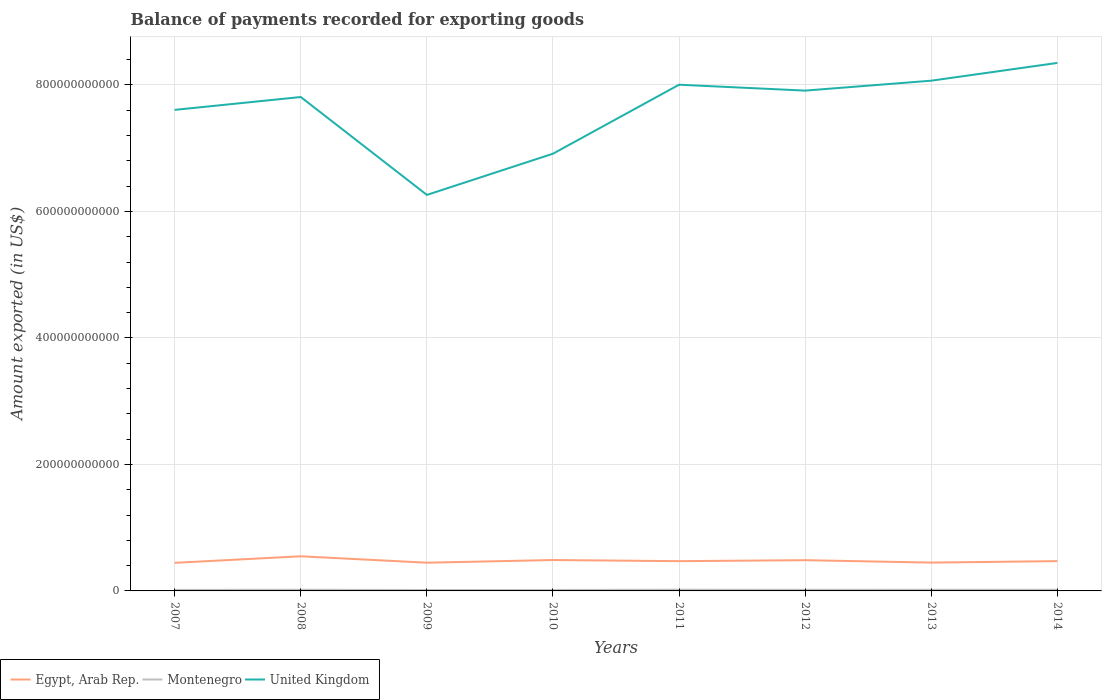Does the line corresponding to United Kingdom intersect with the line corresponding to Egypt, Arab Rep.?
Your answer should be very brief. No. Is the number of lines equal to the number of legend labels?
Make the answer very short. Yes. Across all years, what is the maximum amount exported in Egypt, Arab Rep.?
Offer a terse response. 4.44e+1. In which year was the amount exported in United Kingdom maximum?
Ensure brevity in your answer.  2009. What is the total amount exported in Montenegro in the graph?
Your answer should be very brief. -6.61e+07. What is the difference between the highest and the second highest amount exported in Egypt, Arab Rep.?
Provide a short and direct response. 1.04e+1. What is the difference between the highest and the lowest amount exported in United Kingdom?
Give a very brief answer. 5. How many years are there in the graph?
Give a very brief answer. 8. What is the difference between two consecutive major ticks on the Y-axis?
Provide a short and direct response. 2.00e+11. How many legend labels are there?
Provide a succinct answer. 3. What is the title of the graph?
Provide a short and direct response. Balance of payments recorded for exporting goods. What is the label or title of the X-axis?
Provide a succinct answer. Years. What is the label or title of the Y-axis?
Provide a succinct answer. Amount exported (in US$). What is the Amount exported (in US$) in Egypt, Arab Rep. in 2007?
Your response must be concise. 4.44e+1. What is the Amount exported (in US$) in Montenegro in 2007?
Offer a very short reply. 1.58e+09. What is the Amount exported (in US$) in United Kingdom in 2007?
Keep it short and to the point. 7.61e+11. What is the Amount exported (in US$) in Egypt, Arab Rep. in 2008?
Keep it short and to the point. 5.48e+1. What is the Amount exported (in US$) in Montenegro in 2008?
Offer a very short reply. 1.82e+09. What is the Amount exported (in US$) in United Kingdom in 2008?
Make the answer very short. 7.81e+11. What is the Amount exported (in US$) of Egypt, Arab Rep. in 2009?
Provide a short and direct response. 4.46e+1. What is the Amount exported (in US$) of Montenegro in 2009?
Your answer should be very brief. 1.44e+09. What is the Amount exported (in US$) in United Kingdom in 2009?
Your response must be concise. 6.26e+11. What is the Amount exported (in US$) of Egypt, Arab Rep. in 2010?
Keep it short and to the point. 4.88e+1. What is the Amount exported (in US$) in Montenegro in 2010?
Keep it short and to the point. 1.50e+09. What is the Amount exported (in US$) in United Kingdom in 2010?
Make the answer very short. 6.91e+11. What is the Amount exported (in US$) in Egypt, Arab Rep. in 2011?
Your response must be concise. 4.71e+1. What is the Amount exported (in US$) of Montenegro in 2011?
Provide a short and direct response. 1.93e+09. What is the Amount exported (in US$) of United Kingdom in 2011?
Your answer should be very brief. 8.00e+11. What is the Amount exported (in US$) of Egypt, Arab Rep. in 2012?
Make the answer very short. 4.86e+1. What is the Amount exported (in US$) of Montenegro in 2012?
Provide a short and direct response. 1.71e+09. What is the Amount exported (in US$) in United Kingdom in 2012?
Give a very brief answer. 7.91e+11. What is the Amount exported (in US$) of Egypt, Arab Rep. in 2013?
Provide a succinct answer. 4.48e+1. What is the Amount exported (in US$) of Montenegro in 2013?
Keep it short and to the point. 1.84e+09. What is the Amount exported (in US$) of United Kingdom in 2013?
Your response must be concise. 8.07e+11. What is the Amount exported (in US$) of Egypt, Arab Rep. in 2014?
Your answer should be very brief. 4.71e+1. What is the Amount exported (in US$) of Montenegro in 2014?
Offer a very short reply. 1.84e+09. What is the Amount exported (in US$) in United Kingdom in 2014?
Provide a succinct answer. 8.35e+11. Across all years, what is the maximum Amount exported (in US$) in Egypt, Arab Rep.?
Your answer should be very brief. 5.48e+1. Across all years, what is the maximum Amount exported (in US$) of Montenegro?
Your answer should be compact. 1.93e+09. Across all years, what is the maximum Amount exported (in US$) of United Kingdom?
Provide a short and direct response. 8.35e+11. Across all years, what is the minimum Amount exported (in US$) in Egypt, Arab Rep.?
Your response must be concise. 4.44e+1. Across all years, what is the minimum Amount exported (in US$) in Montenegro?
Ensure brevity in your answer.  1.44e+09. Across all years, what is the minimum Amount exported (in US$) of United Kingdom?
Make the answer very short. 6.26e+11. What is the total Amount exported (in US$) in Egypt, Arab Rep. in the graph?
Give a very brief answer. 3.80e+11. What is the total Amount exported (in US$) of Montenegro in the graph?
Make the answer very short. 1.37e+1. What is the total Amount exported (in US$) in United Kingdom in the graph?
Your answer should be very brief. 6.09e+12. What is the difference between the Amount exported (in US$) of Egypt, Arab Rep. in 2007 and that in 2008?
Give a very brief answer. -1.04e+1. What is the difference between the Amount exported (in US$) in Montenegro in 2007 and that in 2008?
Make the answer very short. -2.34e+08. What is the difference between the Amount exported (in US$) in United Kingdom in 2007 and that in 2008?
Keep it short and to the point. -2.04e+1. What is the difference between the Amount exported (in US$) in Egypt, Arab Rep. in 2007 and that in 2009?
Provide a short and direct response. -2.11e+08. What is the difference between the Amount exported (in US$) in Montenegro in 2007 and that in 2009?
Provide a succinct answer. 1.45e+08. What is the difference between the Amount exported (in US$) of United Kingdom in 2007 and that in 2009?
Give a very brief answer. 1.34e+11. What is the difference between the Amount exported (in US$) in Egypt, Arab Rep. in 2007 and that in 2010?
Your response must be concise. -4.43e+09. What is the difference between the Amount exported (in US$) in Montenegro in 2007 and that in 2010?
Give a very brief answer. 7.93e+07. What is the difference between the Amount exported (in US$) of United Kingdom in 2007 and that in 2010?
Your response must be concise. 6.93e+1. What is the difference between the Amount exported (in US$) of Egypt, Arab Rep. in 2007 and that in 2011?
Keep it short and to the point. -2.66e+09. What is the difference between the Amount exported (in US$) of Montenegro in 2007 and that in 2011?
Your answer should be very brief. -3.48e+08. What is the difference between the Amount exported (in US$) in United Kingdom in 2007 and that in 2011?
Your answer should be compact. -3.98e+1. What is the difference between the Amount exported (in US$) in Egypt, Arab Rep. in 2007 and that in 2012?
Your answer should be very brief. -4.20e+09. What is the difference between the Amount exported (in US$) of Montenegro in 2007 and that in 2012?
Keep it short and to the point. -1.28e+08. What is the difference between the Amount exported (in US$) of United Kingdom in 2007 and that in 2012?
Provide a succinct answer. -3.05e+1. What is the difference between the Amount exported (in US$) in Egypt, Arab Rep. in 2007 and that in 2013?
Ensure brevity in your answer.  -3.97e+08. What is the difference between the Amount exported (in US$) of Montenegro in 2007 and that in 2013?
Give a very brief answer. -2.61e+08. What is the difference between the Amount exported (in US$) in United Kingdom in 2007 and that in 2013?
Make the answer very short. -4.62e+1. What is the difference between the Amount exported (in US$) in Egypt, Arab Rep. in 2007 and that in 2014?
Provide a succinct answer. -2.70e+09. What is the difference between the Amount exported (in US$) of Montenegro in 2007 and that in 2014?
Your answer should be compact. -2.60e+08. What is the difference between the Amount exported (in US$) in United Kingdom in 2007 and that in 2014?
Provide a succinct answer. -7.42e+1. What is the difference between the Amount exported (in US$) of Egypt, Arab Rep. in 2008 and that in 2009?
Ensure brevity in your answer.  1.02e+1. What is the difference between the Amount exported (in US$) of Montenegro in 2008 and that in 2009?
Keep it short and to the point. 3.79e+08. What is the difference between the Amount exported (in US$) of United Kingdom in 2008 and that in 2009?
Make the answer very short. 1.55e+11. What is the difference between the Amount exported (in US$) of Egypt, Arab Rep. in 2008 and that in 2010?
Provide a succinct answer. 5.93e+09. What is the difference between the Amount exported (in US$) in Montenegro in 2008 and that in 2010?
Your answer should be very brief. 3.13e+08. What is the difference between the Amount exported (in US$) in United Kingdom in 2008 and that in 2010?
Your response must be concise. 8.96e+1. What is the difference between the Amount exported (in US$) of Egypt, Arab Rep. in 2008 and that in 2011?
Your response must be concise. 7.71e+09. What is the difference between the Amount exported (in US$) of Montenegro in 2008 and that in 2011?
Ensure brevity in your answer.  -1.14e+08. What is the difference between the Amount exported (in US$) in United Kingdom in 2008 and that in 2011?
Your response must be concise. -1.95e+1. What is the difference between the Amount exported (in US$) in Egypt, Arab Rep. in 2008 and that in 2012?
Your answer should be compact. 6.16e+09. What is the difference between the Amount exported (in US$) in Montenegro in 2008 and that in 2012?
Ensure brevity in your answer.  1.06e+08. What is the difference between the Amount exported (in US$) in United Kingdom in 2008 and that in 2012?
Keep it short and to the point. -1.01e+1. What is the difference between the Amount exported (in US$) in Egypt, Arab Rep. in 2008 and that in 2013?
Offer a very short reply. 9.97e+09. What is the difference between the Amount exported (in US$) in Montenegro in 2008 and that in 2013?
Make the answer very short. -2.67e+07. What is the difference between the Amount exported (in US$) in United Kingdom in 2008 and that in 2013?
Provide a short and direct response. -2.58e+1. What is the difference between the Amount exported (in US$) of Egypt, Arab Rep. in 2008 and that in 2014?
Make the answer very short. 7.66e+09. What is the difference between the Amount exported (in US$) in Montenegro in 2008 and that in 2014?
Your response must be concise. -2.57e+07. What is the difference between the Amount exported (in US$) in United Kingdom in 2008 and that in 2014?
Provide a short and direct response. -5.39e+1. What is the difference between the Amount exported (in US$) in Egypt, Arab Rep. in 2009 and that in 2010?
Your response must be concise. -4.22e+09. What is the difference between the Amount exported (in US$) of Montenegro in 2009 and that in 2010?
Offer a very short reply. -6.61e+07. What is the difference between the Amount exported (in US$) of United Kingdom in 2009 and that in 2010?
Provide a succinct answer. -6.51e+1. What is the difference between the Amount exported (in US$) of Egypt, Arab Rep. in 2009 and that in 2011?
Provide a short and direct response. -2.44e+09. What is the difference between the Amount exported (in US$) in Montenegro in 2009 and that in 2011?
Keep it short and to the point. -4.93e+08. What is the difference between the Amount exported (in US$) in United Kingdom in 2009 and that in 2011?
Provide a succinct answer. -1.74e+11. What is the difference between the Amount exported (in US$) of Egypt, Arab Rep. in 2009 and that in 2012?
Your answer should be very brief. -3.99e+09. What is the difference between the Amount exported (in US$) in Montenegro in 2009 and that in 2012?
Provide a short and direct response. -2.73e+08. What is the difference between the Amount exported (in US$) of United Kingdom in 2009 and that in 2012?
Your response must be concise. -1.65e+11. What is the difference between the Amount exported (in US$) of Egypt, Arab Rep. in 2009 and that in 2013?
Provide a succinct answer. -1.86e+08. What is the difference between the Amount exported (in US$) in Montenegro in 2009 and that in 2013?
Your answer should be very brief. -4.06e+08. What is the difference between the Amount exported (in US$) in United Kingdom in 2009 and that in 2013?
Make the answer very short. -1.81e+11. What is the difference between the Amount exported (in US$) in Egypt, Arab Rep. in 2009 and that in 2014?
Give a very brief answer. -2.49e+09. What is the difference between the Amount exported (in US$) of Montenegro in 2009 and that in 2014?
Your answer should be compact. -4.05e+08. What is the difference between the Amount exported (in US$) in United Kingdom in 2009 and that in 2014?
Provide a succinct answer. -2.09e+11. What is the difference between the Amount exported (in US$) of Egypt, Arab Rep. in 2010 and that in 2011?
Provide a short and direct response. 1.78e+09. What is the difference between the Amount exported (in US$) of Montenegro in 2010 and that in 2011?
Ensure brevity in your answer.  -4.27e+08. What is the difference between the Amount exported (in US$) of United Kingdom in 2010 and that in 2011?
Ensure brevity in your answer.  -1.09e+11. What is the difference between the Amount exported (in US$) in Egypt, Arab Rep. in 2010 and that in 2012?
Your answer should be very brief. 2.30e+08. What is the difference between the Amount exported (in US$) of Montenegro in 2010 and that in 2012?
Your answer should be very brief. -2.07e+08. What is the difference between the Amount exported (in US$) in United Kingdom in 2010 and that in 2012?
Provide a short and direct response. -9.97e+1. What is the difference between the Amount exported (in US$) in Egypt, Arab Rep. in 2010 and that in 2013?
Provide a short and direct response. 4.04e+09. What is the difference between the Amount exported (in US$) in Montenegro in 2010 and that in 2013?
Offer a terse response. -3.40e+08. What is the difference between the Amount exported (in US$) of United Kingdom in 2010 and that in 2013?
Offer a terse response. -1.15e+11. What is the difference between the Amount exported (in US$) of Egypt, Arab Rep. in 2010 and that in 2014?
Offer a terse response. 1.73e+09. What is the difference between the Amount exported (in US$) of Montenegro in 2010 and that in 2014?
Offer a terse response. -3.39e+08. What is the difference between the Amount exported (in US$) in United Kingdom in 2010 and that in 2014?
Your answer should be very brief. -1.44e+11. What is the difference between the Amount exported (in US$) of Egypt, Arab Rep. in 2011 and that in 2012?
Provide a succinct answer. -1.55e+09. What is the difference between the Amount exported (in US$) of Montenegro in 2011 and that in 2012?
Keep it short and to the point. 2.20e+08. What is the difference between the Amount exported (in US$) of United Kingdom in 2011 and that in 2012?
Keep it short and to the point. 9.33e+09. What is the difference between the Amount exported (in US$) of Egypt, Arab Rep. in 2011 and that in 2013?
Provide a short and direct response. 2.26e+09. What is the difference between the Amount exported (in US$) in Montenegro in 2011 and that in 2013?
Keep it short and to the point. 8.72e+07. What is the difference between the Amount exported (in US$) in United Kingdom in 2011 and that in 2013?
Offer a very short reply. -6.37e+09. What is the difference between the Amount exported (in US$) in Egypt, Arab Rep. in 2011 and that in 2014?
Your answer should be very brief. -4.83e+07. What is the difference between the Amount exported (in US$) in Montenegro in 2011 and that in 2014?
Offer a very short reply. 8.82e+07. What is the difference between the Amount exported (in US$) in United Kingdom in 2011 and that in 2014?
Keep it short and to the point. -3.44e+1. What is the difference between the Amount exported (in US$) in Egypt, Arab Rep. in 2012 and that in 2013?
Your response must be concise. 3.81e+09. What is the difference between the Amount exported (in US$) in Montenegro in 2012 and that in 2013?
Offer a very short reply. -1.33e+08. What is the difference between the Amount exported (in US$) in United Kingdom in 2012 and that in 2013?
Your response must be concise. -1.57e+1. What is the difference between the Amount exported (in US$) of Egypt, Arab Rep. in 2012 and that in 2014?
Provide a succinct answer. 1.50e+09. What is the difference between the Amount exported (in US$) in Montenegro in 2012 and that in 2014?
Your answer should be very brief. -1.32e+08. What is the difference between the Amount exported (in US$) in United Kingdom in 2012 and that in 2014?
Provide a short and direct response. -4.38e+1. What is the difference between the Amount exported (in US$) in Egypt, Arab Rep. in 2013 and that in 2014?
Your answer should be very brief. -2.31e+09. What is the difference between the Amount exported (in US$) of Montenegro in 2013 and that in 2014?
Your answer should be compact. 9.82e+05. What is the difference between the Amount exported (in US$) of United Kingdom in 2013 and that in 2014?
Offer a very short reply. -2.81e+1. What is the difference between the Amount exported (in US$) of Egypt, Arab Rep. in 2007 and the Amount exported (in US$) of Montenegro in 2008?
Your response must be concise. 4.26e+1. What is the difference between the Amount exported (in US$) of Egypt, Arab Rep. in 2007 and the Amount exported (in US$) of United Kingdom in 2008?
Provide a succinct answer. -7.36e+11. What is the difference between the Amount exported (in US$) in Montenegro in 2007 and the Amount exported (in US$) in United Kingdom in 2008?
Provide a short and direct response. -7.79e+11. What is the difference between the Amount exported (in US$) in Egypt, Arab Rep. in 2007 and the Amount exported (in US$) in Montenegro in 2009?
Offer a terse response. 4.30e+1. What is the difference between the Amount exported (in US$) in Egypt, Arab Rep. in 2007 and the Amount exported (in US$) in United Kingdom in 2009?
Your answer should be very brief. -5.82e+11. What is the difference between the Amount exported (in US$) of Montenegro in 2007 and the Amount exported (in US$) of United Kingdom in 2009?
Keep it short and to the point. -6.25e+11. What is the difference between the Amount exported (in US$) in Egypt, Arab Rep. in 2007 and the Amount exported (in US$) in Montenegro in 2010?
Provide a short and direct response. 4.29e+1. What is the difference between the Amount exported (in US$) of Egypt, Arab Rep. in 2007 and the Amount exported (in US$) of United Kingdom in 2010?
Provide a succinct answer. -6.47e+11. What is the difference between the Amount exported (in US$) of Montenegro in 2007 and the Amount exported (in US$) of United Kingdom in 2010?
Ensure brevity in your answer.  -6.90e+11. What is the difference between the Amount exported (in US$) in Egypt, Arab Rep. in 2007 and the Amount exported (in US$) in Montenegro in 2011?
Your response must be concise. 4.25e+1. What is the difference between the Amount exported (in US$) in Egypt, Arab Rep. in 2007 and the Amount exported (in US$) in United Kingdom in 2011?
Your response must be concise. -7.56e+11. What is the difference between the Amount exported (in US$) of Montenegro in 2007 and the Amount exported (in US$) of United Kingdom in 2011?
Your answer should be compact. -7.99e+11. What is the difference between the Amount exported (in US$) in Egypt, Arab Rep. in 2007 and the Amount exported (in US$) in Montenegro in 2012?
Make the answer very short. 4.27e+1. What is the difference between the Amount exported (in US$) in Egypt, Arab Rep. in 2007 and the Amount exported (in US$) in United Kingdom in 2012?
Provide a succinct answer. -7.47e+11. What is the difference between the Amount exported (in US$) of Montenegro in 2007 and the Amount exported (in US$) of United Kingdom in 2012?
Ensure brevity in your answer.  -7.89e+11. What is the difference between the Amount exported (in US$) of Egypt, Arab Rep. in 2007 and the Amount exported (in US$) of Montenegro in 2013?
Your response must be concise. 4.26e+1. What is the difference between the Amount exported (in US$) in Egypt, Arab Rep. in 2007 and the Amount exported (in US$) in United Kingdom in 2013?
Provide a short and direct response. -7.62e+11. What is the difference between the Amount exported (in US$) of Montenegro in 2007 and the Amount exported (in US$) of United Kingdom in 2013?
Give a very brief answer. -8.05e+11. What is the difference between the Amount exported (in US$) in Egypt, Arab Rep. in 2007 and the Amount exported (in US$) in Montenegro in 2014?
Offer a terse response. 4.26e+1. What is the difference between the Amount exported (in US$) in Egypt, Arab Rep. in 2007 and the Amount exported (in US$) in United Kingdom in 2014?
Provide a short and direct response. -7.90e+11. What is the difference between the Amount exported (in US$) of Montenegro in 2007 and the Amount exported (in US$) of United Kingdom in 2014?
Your answer should be very brief. -8.33e+11. What is the difference between the Amount exported (in US$) of Egypt, Arab Rep. in 2008 and the Amount exported (in US$) of Montenegro in 2009?
Provide a succinct answer. 5.33e+1. What is the difference between the Amount exported (in US$) of Egypt, Arab Rep. in 2008 and the Amount exported (in US$) of United Kingdom in 2009?
Make the answer very short. -5.71e+11. What is the difference between the Amount exported (in US$) of Montenegro in 2008 and the Amount exported (in US$) of United Kingdom in 2009?
Provide a succinct answer. -6.24e+11. What is the difference between the Amount exported (in US$) of Egypt, Arab Rep. in 2008 and the Amount exported (in US$) of Montenegro in 2010?
Offer a very short reply. 5.33e+1. What is the difference between the Amount exported (in US$) in Egypt, Arab Rep. in 2008 and the Amount exported (in US$) in United Kingdom in 2010?
Your response must be concise. -6.37e+11. What is the difference between the Amount exported (in US$) in Montenegro in 2008 and the Amount exported (in US$) in United Kingdom in 2010?
Offer a very short reply. -6.89e+11. What is the difference between the Amount exported (in US$) of Egypt, Arab Rep. in 2008 and the Amount exported (in US$) of Montenegro in 2011?
Ensure brevity in your answer.  5.28e+1. What is the difference between the Amount exported (in US$) of Egypt, Arab Rep. in 2008 and the Amount exported (in US$) of United Kingdom in 2011?
Offer a terse response. -7.46e+11. What is the difference between the Amount exported (in US$) of Montenegro in 2008 and the Amount exported (in US$) of United Kingdom in 2011?
Provide a succinct answer. -7.99e+11. What is the difference between the Amount exported (in US$) in Egypt, Arab Rep. in 2008 and the Amount exported (in US$) in Montenegro in 2012?
Provide a succinct answer. 5.31e+1. What is the difference between the Amount exported (in US$) of Egypt, Arab Rep. in 2008 and the Amount exported (in US$) of United Kingdom in 2012?
Offer a very short reply. -7.36e+11. What is the difference between the Amount exported (in US$) of Montenegro in 2008 and the Amount exported (in US$) of United Kingdom in 2012?
Keep it short and to the point. -7.89e+11. What is the difference between the Amount exported (in US$) in Egypt, Arab Rep. in 2008 and the Amount exported (in US$) in Montenegro in 2013?
Keep it short and to the point. 5.29e+1. What is the difference between the Amount exported (in US$) of Egypt, Arab Rep. in 2008 and the Amount exported (in US$) of United Kingdom in 2013?
Offer a terse response. -7.52e+11. What is the difference between the Amount exported (in US$) of Montenegro in 2008 and the Amount exported (in US$) of United Kingdom in 2013?
Ensure brevity in your answer.  -8.05e+11. What is the difference between the Amount exported (in US$) in Egypt, Arab Rep. in 2008 and the Amount exported (in US$) in Montenegro in 2014?
Your answer should be very brief. 5.29e+1. What is the difference between the Amount exported (in US$) of Egypt, Arab Rep. in 2008 and the Amount exported (in US$) of United Kingdom in 2014?
Keep it short and to the point. -7.80e+11. What is the difference between the Amount exported (in US$) in Montenegro in 2008 and the Amount exported (in US$) in United Kingdom in 2014?
Provide a short and direct response. -8.33e+11. What is the difference between the Amount exported (in US$) in Egypt, Arab Rep. in 2009 and the Amount exported (in US$) in Montenegro in 2010?
Offer a terse response. 4.31e+1. What is the difference between the Amount exported (in US$) of Egypt, Arab Rep. in 2009 and the Amount exported (in US$) of United Kingdom in 2010?
Keep it short and to the point. -6.47e+11. What is the difference between the Amount exported (in US$) of Montenegro in 2009 and the Amount exported (in US$) of United Kingdom in 2010?
Provide a succinct answer. -6.90e+11. What is the difference between the Amount exported (in US$) in Egypt, Arab Rep. in 2009 and the Amount exported (in US$) in Montenegro in 2011?
Keep it short and to the point. 4.27e+1. What is the difference between the Amount exported (in US$) of Egypt, Arab Rep. in 2009 and the Amount exported (in US$) of United Kingdom in 2011?
Your response must be concise. -7.56e+11. What is the difference between the Amount exported (in US$) in Montenegro in 2009 and the Amount exported (in US$) in United Kingdom in 2011?
Ensure brevity in your answer.  -7.99e+11. What is the difference between the Amount exported (in US$) of Egypt, Arab Rep. in 2009 and the Amount exported (in US$) of Montenegro in 2012?
Provide a succinct answer. 4.29e+1. What is the difference between the Amount exported (in US$) of Egypt, Arab Rep. in 2009 and the Amount exported (in US$) of United Kingdom in 2012?
Provide a succinct answer. -7.46e+11. What is the difference between the Amount exported (in US$) of Montenegro in 2009 and the Amount exported (in US$) of United Kingdom in 2012?
Keep it short and to the point. -7.90e+11. What is the difference between the Amount exported (in US$) in Egypt, Arab Rep. in 2009 and the Amount exported (in US$) in Montenegro in 2013?
Your answer should be very brief. 4.28e+1. What is the difference between the Amount exported (in US$) in Egypt, Arab Rep. in 2009 and the Amount exported (in US$) in United Kingdom in 2013?
Provide a short and direct response. -7.62e+11. What is the difference between the Amount exported (in US$) in Montenegro in 2009 and the Amount exported (in US$) in United Kingdom in 2013?
Your response must be concise. -8.05e+11. What is the difference between the Amount exported (in US$) of Egypt, Arab Rep. in 2009 and the Amount exported (in US$) of Montenegro in 2014?
Provide a succinct answer. 4.28e+1. What is the difference between the Amount exported (in US$) of Egypt, Arab Rep. in 2009 and the Amount exported (in US$) of United Kingdom in 2014?
Offer a very short reply. -7.90e+11. What is the difference between the Amount exported (in US$) of Montenegro in 2009 and the Amount exported (in US$) of United Kingdom in 2014?
Give a very brief answer. -8.33e+11. What is the difference between the Amount exported (in US$) in Egypt, Arab Rep. in 2010 and the Amount exported (in US$) in Montenegro in 2011?
Provide a succinct answer. 4.69e+1. What is the difference between the Amount exported (in US$) in Egypt, Arab Rep. in 2010 and the Amount exported (in US$) in United Kingdom in 2011?
Keep it short and to the point. -7.52e+11. What is the difference between the Amount exported (in US$) of Montenegro in 2010 and the Amount exported (in US$) of United Kingdom in 2011?
Your answer should be compact. -7.99e+11. What is the difference between the Amount exported (in US$) of Egypt, Arab Rep. in 2010 and the Amount exported (in US$) of Montenegro in 2012?
Provide a succinct answer. 4.71e+1. What is the difference between the Amount exported (in US$) of Egypt, Arab Rep. in 2010 and the Amount exported (in US$) of United Kingdom in 2012?
Offer a terse response. -7.42e+11. What is the difference between the Amount exported (in US$) in Montenegro in 2010 and the Amount exported (in US$) in United Kingdom in 2012?
Ensure brevity in your answer.  -7.90e+11. What is the difference between the Amount exported (in US$) of Egypt, Arab Rep. in 2010 and the Amount exported (in US$) of Montenegro in 2013?
Keep it short and to the point. 4.70e+1. What is the difference between the Amount exported (in US$) of Egypt, Arab Rep. in 2010 and the Amount exported (in US$) of United Kingdom in 2013?
Your answer should be compact. -7.58e+11. What is the difference between the Amount exported (in US$) of Montenegro in 2010 and the Amount exported (in US$) of United Kingdom in 2013?
Your answer should be very brief. -8.05e+11. What is the difference between the Amount exported (in US$) of Egypt, Arab Rep. in 2010 and the Amount exported (in US$) of Montenegro in 2014?
Offer a terse response. 4.70e+1. What is the difference between the Amount exported (in US$) of Egypt, Arab Rep. in 2010 and the Amount exported (in US$) of United Kingdom in 2014?
Keep it short and to the point. -7.86e+11. What is the difference between the Amount exported (in US$) in Montenegro in 2010 and the Amount exported (in US$) in United Kingdom in 2014?
Your answer should be compact. -8.33e+11. What is the difference between the Amount exported (in US$) in Egypt, Arab Rep. in 2011 and the Amount exported (in US$) in Montenegro in 2012?
Keep it short and to the point. 4.53e+1. What is the difference between the Amount exported (in US$) of Egypt, Arab Rep. in 2011 and the Amount exported (in US$) of United Kingdom in 2012?
Ensure brevity in your answer.  -7.44e+11. What is the difference between the Amount exported (in US$) in Montenegro in 2011 and the Amount exported (in US$) in United Kingdom in 2012?
Offer a very short reply. -7.89e+11. What is the difference between the Amount exported (in US$) in Egypt, Arab Rep. in 2011 and the Amount exported (in US$) in Montenegro in 2013?
Your answer should be compact. 4.52e+1. What is the difference between the Amount exported (in US$) in Egypt, Arab Rep. in 2011 and the Amount exported (in US$) in United Kingdom in 2013?
Your answer should be compact. -7.60e+11. What is the difference between the Amount exported (in US$) of Montenegro in 2011 and the Amount exported (in US$) of United Kingdom in 2013?
Offer a very short reply. -8.05e+11. What is the difference between the Amount exported (in US$) of Egypt, Arab Rep. in 2011 and the Amount exported (in US$) of Montenegro in 2014?
Offer a very short reply. 4.52e+1. What is the difference between the Amount exported (in US$) of Egypt, Arab Rep. in 2011 and the Amount exported (in US$) of United Kingdom in 2014?
Provide a succinct answer. -7.88e+11. What is the difference between the Amount exported (in US$) of Montenegro in 2011 and the Amount exported (in US$) of United Kingdom in 2014?
Provide a short and direct response. -8.33e+11. What is the difference between the Amount exported (in US$) in Egypt, Arab Rep. in 2012 and the Amount exported (in US$) in Montenegro in 2013?
Offer a very short reply. 4.68e+1. What is the difference between the Amount exported (in US$) of Egypt, Arab Rep. in 2012 and the Amount exported (in US$) of United Kingdom in 2013?
Your response must be concise. -7.58e+11. What is the difference between the Amount exported (in US$) in Montenegro in 2012 and the Amount exported (in US$) in United Kingdom in 2013?
Offer a very short reply. -8.05e+11. What is the difference between the Amount exported (in US$) in Egypt, Arab Rep. in 2012 and the Amount exported (in US$) in Montenegro in 2014?
Keep it short and to the point. 4.68e+1. What is the difference between the Amount exported (in US$) in Egypt, Arab Rep. in 2012 and the Amount exported (in US$) in United Kingdom in 2014?
Offer a very short reply. -7.86e+11. What is the difference between the Amount exported (in US$) in Montenegro in 2012 and the Amount exported (in US$) in United Kingdom in 2014?
Your answer should be compact. -8.33e+11. What is the difference between the Amount exported (in US$) of Egypt, Arab Rep. in 2013 and the Amount exported (in US$) of Montenegro in 2014?
Your answer should be compact. 4.30e+1. What is the difference between the Amount exported (in US$) in Egypt, Arab Rep. in 2013 and the Amount exported (in US$) in United Kingdom in 2014?
Ensure brevity in your answer.  -7.90e+11. What is the difference between the Amount exported (in US$) of Montenegro in 2013 and the Amount exported (in US$) of United Kingdom in 2014?
Provide a succinct answer. -8.33e+11. What is the average Amount exported (in US$) of Egypt, Arab Rep. per year?
Keep it short and to the point. 4.75e+1. What is the average Amount exported (in US$) of Montenegro per year?
Offer a very short reply. 1.71e+09. What is the average Amount exported (in US$) in United Kingdom per year?
Your answer should be very brief. 7.61e+11. In the year 2007, what is the difference between the Amount exported (in US$) in Egypt, Arab Rep. and Amount exported (in US$) in Montenegro?
Provide a succinct answer. 4.28e+1. In the year 2007, what is the difference between the Amount exported (in US$) in Egypt, Arab Rep. and Amount exported (in US$) in United Kingdom?
Provide a succinct answer. -7.16e+11. In the year 2007, what is the difference between the Amount exported (in US$) of Montenegro and Amount exported (in US$) of United Kingdom?
Ensure brevity in your answer.  -7.59e+11. In the year 2008, what is the difference between the Amount exported (in US$) in Egypt, Arab Rep. and Amount exported (in US$) in Montenegro?
Provide a succinct answer. 5.29e+1. In the year 2008, what is the difference between the Amount exported (in US$) in Egypt, Arab Rep. and Amount exported (in US$) in United Kingdom?
Provide a short and direct response. -7.26e+11. In the year 2008, what is the difference between the Amount exported (in US$) of Montenegro and Amount exported (in US$) of United Kingdom?
Your answer should be compact. -7.79e+11. In the year 2009, what is the difference between the Amount exported (in US$) of Egypt, Arab Rep. and Amount exported (in US$) of Montenegro?
Make the answer very short. 4.32e+1. In the year 2009, what is the difference between the Amount exported (in US$) in Egypt, Arab Rep. and Amount exported (in US$) in United Kingdom?
Keep it short and to the point. -5.82e+11. In the year 2009, what is the difference between the Amount exported (in US$) of Montenegro and Amount exported (in US$) of United Kingdom?
Give a very brief answer. -6.25e+11. In the year 2010, what is the difference between the Amount exported (in US$) in Egypt, Arab Rep. and Amount exported (in US$) in Montenegro?
Ensure brevity in your answer.  4.73e+1. In the year 2010, what is the difference between the Amount exported (in US$) of Egypt, Arab Rep. and Amount exported (in US$) of United Kingdom?
Give a very brief answer. -6.42e+11. In the year 2010, what is the difference between the Amount exported (in US$) of Montenegro and Amount exported (in US$) of United Kingdom?
Your answer should be compact. -6.90e+11. In the year 2011, what is the difference between the Amount exported (in US$) of Egypt, Arab Rep. and Amount exported (in US$) of Montenegro?
Keep it short and to the point. 4.51e+1. In the year 2011, what is the difference between the Amount exported (in US$) in Egypt, Arab Rep. and Amount exported (in US$) in United Kingdom?
Make the answer very short. -7.53e+11. In the year 2011, what is the difference between the Amount exported (in US$) of Montenegro and Amount exported (in US$) of United Kingdom?
Offer a terse response. -7.98e+11. In the year 2012, what is the difference between the Amount exported (in US$) in Egypt, Arab Rep. and Amount exported (in US$) in Montenegro?
Your response must be concise. 4.69e+1. In the year 2012, what is the difference between the Amount exported (in US$) in Egypt, Arab Rep. and Amount exported (in US$) in United Kingdom?
Provide a succinct answer. -7.42e+11. In the year 2012, what is the difference between the Amount exported (in US$) of Montenegro and Amount exported (in US$) of United Kingdom?
Make the answer very short. -7.89e+11. In the year 2013, what is the difference between the Amount exported (in US$) of Egypt, Arab Rep. and Amount exported (in US$) of Montenegro?
Offer a very short reply. 4.30e+1. In the year 2013, what is the difference between the Amount exported (in US$) of Egypt, Arab Rep. and Amount exported (in US$) of United Kingdom?
Ensure brevity in your answer.  -7.62e+11. In the year 2013, what is the difference between the Amount exported (in US$) of Montenegro and Amount exported (in US$) of United Kingdom?
Provide a short and direct response. -8.05e+11. In the year 2014, what is the difference between the Amount exported (in US$) of Egypt, Arab Rep. and Amount exported (in US$) of Montenegro?
Provide a succinct answer. 4.53e+1. In the year 2014, what is the difference between the Amount exported (in US$) of Egypt, Arab Rep. and Amount exported (in US$) of United Kingdom?
Offer a very short reply. -7.88e+11. In the year 2014, what is the difference between the Amount exported (in US$) in Montenegro and Amount exported (in US$) in United Kingdom?
Offer a very short reply. -8.33e+11. What is the ratio of the Amount exported (in US$) of Egypt, Arab Rep. in 2007 to that in 2008?
Offer a very short reply. 0.81. What is the ratio of the Amount exported (in US$) in Montenegro in 2007 to that in 2008?
Keep it short and to the point. 0.87. What is the ratio of the Amount exported (in US$) of United Kingdom in 2007 to that in 2008?
Give a very brief answer. 0.97. What is the ratio of the Amount exported (in US$) in Egypt, Arab Rep. in 2007 to that in 2009?
Provide a succinct answer. 1. What is the ratio of the Amount exported (in US$) in Montenegro in 2007 to that in 2009?
Your answer should be very brief. 1.1. What is the ratio of the Amount exported (in US$) in United Kingdom in 2007 to that in 2009?
Your answer should be very brief. 1.21. What is the ratio of the Amount exported (in US$) of Egypt, Arab Rep. in 2007 to that in 2010?
Your answer should be very brief. 0.91. What is the ratio of the Amount exported (in US$) in Montenegro in 2007 to that in 2010?
Offer a terse response. 1.05. What is the ratio of the Amount exported (in US$) of United Kingdom in 2007 to that in 2010?
Your answer should be compact. 1.1. What is the ratio of the Amount exported (in US$) of Egypt, Arab Rep. in 2007 to that in 2011?
Make the answer very short. 0.94. What is the ratio of the Amount exported (in US$) of Montenegro in 2007 to that in 2011?
Provide a succinct answer. 0.82. What is the ratio of the Amount exported (in US$) of United Kingdom in 2007 to that in 2011?
Your answer should be very brief. 0.95. What is the ratio of the Amount exported (in US$) in Egypt, Arab Rep. in 2007 to that in 2012?
Your answer should be compact. 0.91. What is the ratio of the Amount exported (in US$) of Montenegro in 2007 to that in 2012?
Give a very brief answer. 0.93. What is the ratio of the Amount exported (in US$) in United Kingdom in 2007 to that in 2012?
Your answer should be compact. 0.96. What is the ratio of the Amount exported (in US$) of Egypt, Arab Rep. in 2007 to that in 2013?
Ensure brevity in your answer.  0.99. What is the ratio of the Amount exported (in US$) of Montenegro in 2007 to that in 2013?
Make the answer very short. 0.86. What is the ratio of the Amount exported (in US$) of United Kingdom in 2007 to that in 2013?
Provide a succinct answer. 0.94. What is the ratio of the Amount exported (in US$) of Egypt, Arab Rep. in 2007 to that in 2014?
Ensure brevity in your answer.  0.94. What is the ratio of the Amount exported (in US$) of Montenegro in 2007 to that in 2014?
Your answer should be compact. 0.86. What is the ratio of the Amount exported (in US$) of United Kingdom in 2007 to that in 2014?
Ensure brevity in your answer.  0.91. What is the ratio of the Amount exported (in US$) in Egypt, Arab Rep. in 2008 to that in 2009?
Provide a succinct answer. 1.23. What is the ratio of the Amount exported (in US$) in Montenegro in 2008 to that in 2009?
Ensure brevity in your answer.  1.26. What is the ratio of the Amount exported (in US$) of United Kingdom in 2008 to that in 2009?
Give a very brief answer. 1.25. What is the ratio of the Amount exported (in US$) of Egypt, Arab Rep. in 2008 to that in 2010?
Ensure brevity in your answer.  1.12. What is the ratio of the Amount exported (in US$) of Montenegro in 2008 to that in 2010?
Offer a terse response. 1.21. What is the ratio of the Amount exported (in US$) in United Kingdom in 2008 to that in 2010?
Ensure brevity in your answer.  1.13. What is the ratio of the Amount exported (in US$) of Egypt, Arab Rep. in 2008 to that in 2011?
Your answer should be compact. 1.16. What is the ratio of the Amount exported (in US$) in Montenegro in 2008 to that in 2011?
Provide a succinct answer. 0.94. What is the ratio of the Amount exported (in US$) in United Kingdom in 2008 to that in 2011?
Offer a terse response. 0.98. What is the ratio of the Amount exported (in US$) of Egypt, Arab Rep. in 2008 to that in 2012?
Keep it short and to the point. 1.13. What is the ratio of the Amount exported (in US$) of Montenegro in 2008 to that in 2012?
Offer a terse response. 1.06. What is the ratio of the Amount exported (in US$) in United Kingdom in 2008 to that in 2012?
Provide a short and direct response. 0.99. What is the ratio of the Amount exported (in US$) in Egypt, Arab Rep. in 2008 to that in 2013?
Give a very brief answer. 1.22. What is the ratio of the Amount exported (in US$) of Montenegro in 2008 to that in 2013?
Provide a short and direct response. 0.99. What is the ratio of the Amount exported (in US$) in Egypt, Arab Rep. in 2008 to that in 2014?
Keep it short and to the point. 1.16. What is the ratio of the Amount exported (in US$) in United Kingdom in 2008 to that in 2014?
Offer a very short reply. 0.94. What is the ratio of the Amount exported (in US$) in Egypt, Arab Rep. in 2009 to that in 2010?
Provide a short and direct response. 0.91. What is the ratio of the Amount exported (in US$) in Montenegro in 2009 to that in 2010?
Your answer should be compact. 0.96. What is the ratio of the Amount exported (in US$) in United Kingdom in 2009 to that in 2010?
Keep it short and to the point. 0.91. What is the ratio of the Amount exported (in US$) of Egypt, Arab Rep. in 2009 to that in 2011?
Give a very brief answer. 0.95. What is the ratio of the Amount exported (in US$) of Montenegro in 2009 to that in 2011?
Make the answer very short. 0.74. What is the ratio of the Amount exported (in US$) in United Kingdom in 2009 to that in 2011?
Offer a terse response. 0.78. What is the ratio of the Amount exported (in US$) in Egypt, Arab Rep. in 2009 to that in 2012?
Make the answer very short. 0.92. What is the ratio of the Amount exported (in US$) in Montenegro in 2009 to that in 2012?
Make the answer very short. 0.84. What is the ratio of the Amount exported (in US$) in United Kingdom in 2009 to that in 2012?
Give a very brief answer. 0.79. What is the ratio of the Amount exported (in US$) of Montenegro in 2009 to that in 2013?
Your answer should be compact. 0.78. What is the ratio of the Amount exported (in US$) in United Kingdom in 2009 to that in 2013?
Make the answer very short. 0.78. What is the ratio of the Amount exported (in US$) in Egypt, Arab Rep. in 2009 to that in 2014?
Keep it short and to the point. 0.95. What is the ratio of the Amount exported (in US$) of Montenegro in 2009 to that in 2014?
Your response must be concise. 0.78. What is the ratio of the Amount exported (in US$) in United Kingdom in 2009 to that in 2014?
Offer a terse response. 0.75. What is the ratio of the Amount exported (in US$) in Egypt, Arab Rep. in 2010 to that in 2011?
Your response must be concise. 1.04. What is the ratio of the Amount exported (in US$) of Montenegro in 2010 to that in 2011?
Your answer should be compact. 0.78. What is the ratio of the Amount exported (in US$) of United Kingdom in 2010 to that in 2011?
Offer a terse response. 0.86. What is the ratio of the Amount exported (in US$) in Montenegro in 2010 to that in 2012?
Offer a very short reply. 0.88. What is the ratio of the Amount exported (in US$) of United Kingdom in 2010 to that in 2012?
Make the answer very short. 0.87. What is the ratio of the Amount exported (in US$) in Egypt, Arab Rep. in 2010 to that in 2013?
Provide a succinct answer. 1.09. What is the ratio of the Amount exported (in US$) of Montenegro in 2010 to that in 2013?
Make the answer very short. 0.82. What is the ratio of the Amount exported (in US$) in United Kingdom in 2010 to that in 2013?
Ensure brevity in your answer.  0.86. What is the ratio of the Amount exported (in US$) in Egypt, Arab Rep. in 2010 to that in 2014?
Give a very brief answer. 1.04. What is the ratio of the Amount exported (in US$) in Montenegro in 2010 to that in 2014?
Ensure brevity in your answer.  0.82. What is the ratio of the Amount exported (in US$) in United Kingdom in 2010 to that in 2014?
Your response must be concise. 0.83. What is the ratio of the Amount exported (in US$) of Egypt, Arab Rep. in 2011 to that in 2012?
Offer a very short reply. 0.97. What is the ratio of the Amount exported (in US$) of Montenegro in 2011 to that in 2012?
Provide a succinct answer. 1.13. What is the ratio of the Amount exported (in US$) in United Kingdom in 2011 to that in 2012?
Ensure brevity in your answer.  1.01. What is the ratio of the Amount exported (in US$) of Egypt, Arab Rep. in 2011 to that in 2013?
Your answer should be very brief. 1.05. What is the ratio of the Amount exported (in US$) in Montenegro in 2011 to that in 2013?
Give a very brief answer. 1.05. What is the ratio of the Amount exported (in US$) of Egypt, Arab Rep. in 2011 to that in 2014?
Keep it short and to the point. 1. What is the ratio of the Amount exported (in US$) of Montenegro in 2011 to that in 2014?
Offer a very short reply. 1.05. What is the ratio of the Amount exported (in US$) of United Kingdom in 2011 to that in 2014?
Ensure brevity in your answer.  0.96. What is the ratio of the Amount exported (in US$) of Egypt, Arab Rep. in 2012 to that in 2013?
Offer a terse response. 1.08. What is the ratio of the Amount exported (in US$) of Montenegro in 2012 to that in 2013?
Provide a short and direct response. 0.93. What is the ratio of the Amount exported (in US$) in United Kingdom in 2012 to that in 2013?
Your response must be concise. 0.98. What is the ratio of the Amount exported (in US$) in Egypt, Arab Rep. in 2012 to that in 2014?
Give a very brief answer. 1.03. What is the ratio of the Amount exported (in US$) in Montenegro in 2012 to that in 2014?
Your answer should be very brief. 0.93. What is the ratio of the Amount exported (in US$) in United Kingdom in 2012 to that in 2014?
Your answer should be compact. 0.95. What is the ratio of the Amount exported (in US$) in Egypt, Arab Rep. in 2013 to that in 2014?
Your answer should be compact. 0.95. What is the ratio of the Amount exported (in US$) in Montenegro in 2013 to that in 2014?
Offer a terse response. 1. What is the ratio of the Amount exported (in US$) of United Kingdom in 2013 to that in 2014?
Your response must be concise. 0.97. What is the difference between the highest and the second highest Amount exported (in US$) in Egypt, Arab Rep.?
Your answer should be very brief. 5.93e+09. What is the difference between the highest and the second highest Amount exported (in US$) in Montenegro?
Your answer should be compact. 8.72e+07. What is the difference between the highest and the second highest Amount exported (in US$) of United Kingdom?
Give a very brief answer. 2.81e+1. What is the difference between the highest and the lowest Amount exported (in US$) of Egypt, Arab Rep.?
Make the answer very short. 1.04e+1. What is the difference between the highest and the lowest Amount exported (in US$) in Montenegro?
Make the answer very short. 4.93e+08. What is the difference between the highest and the lowest Amount exported (in US$) of United Kingdom?
Provide a short and direct response. 2.09e+11. 